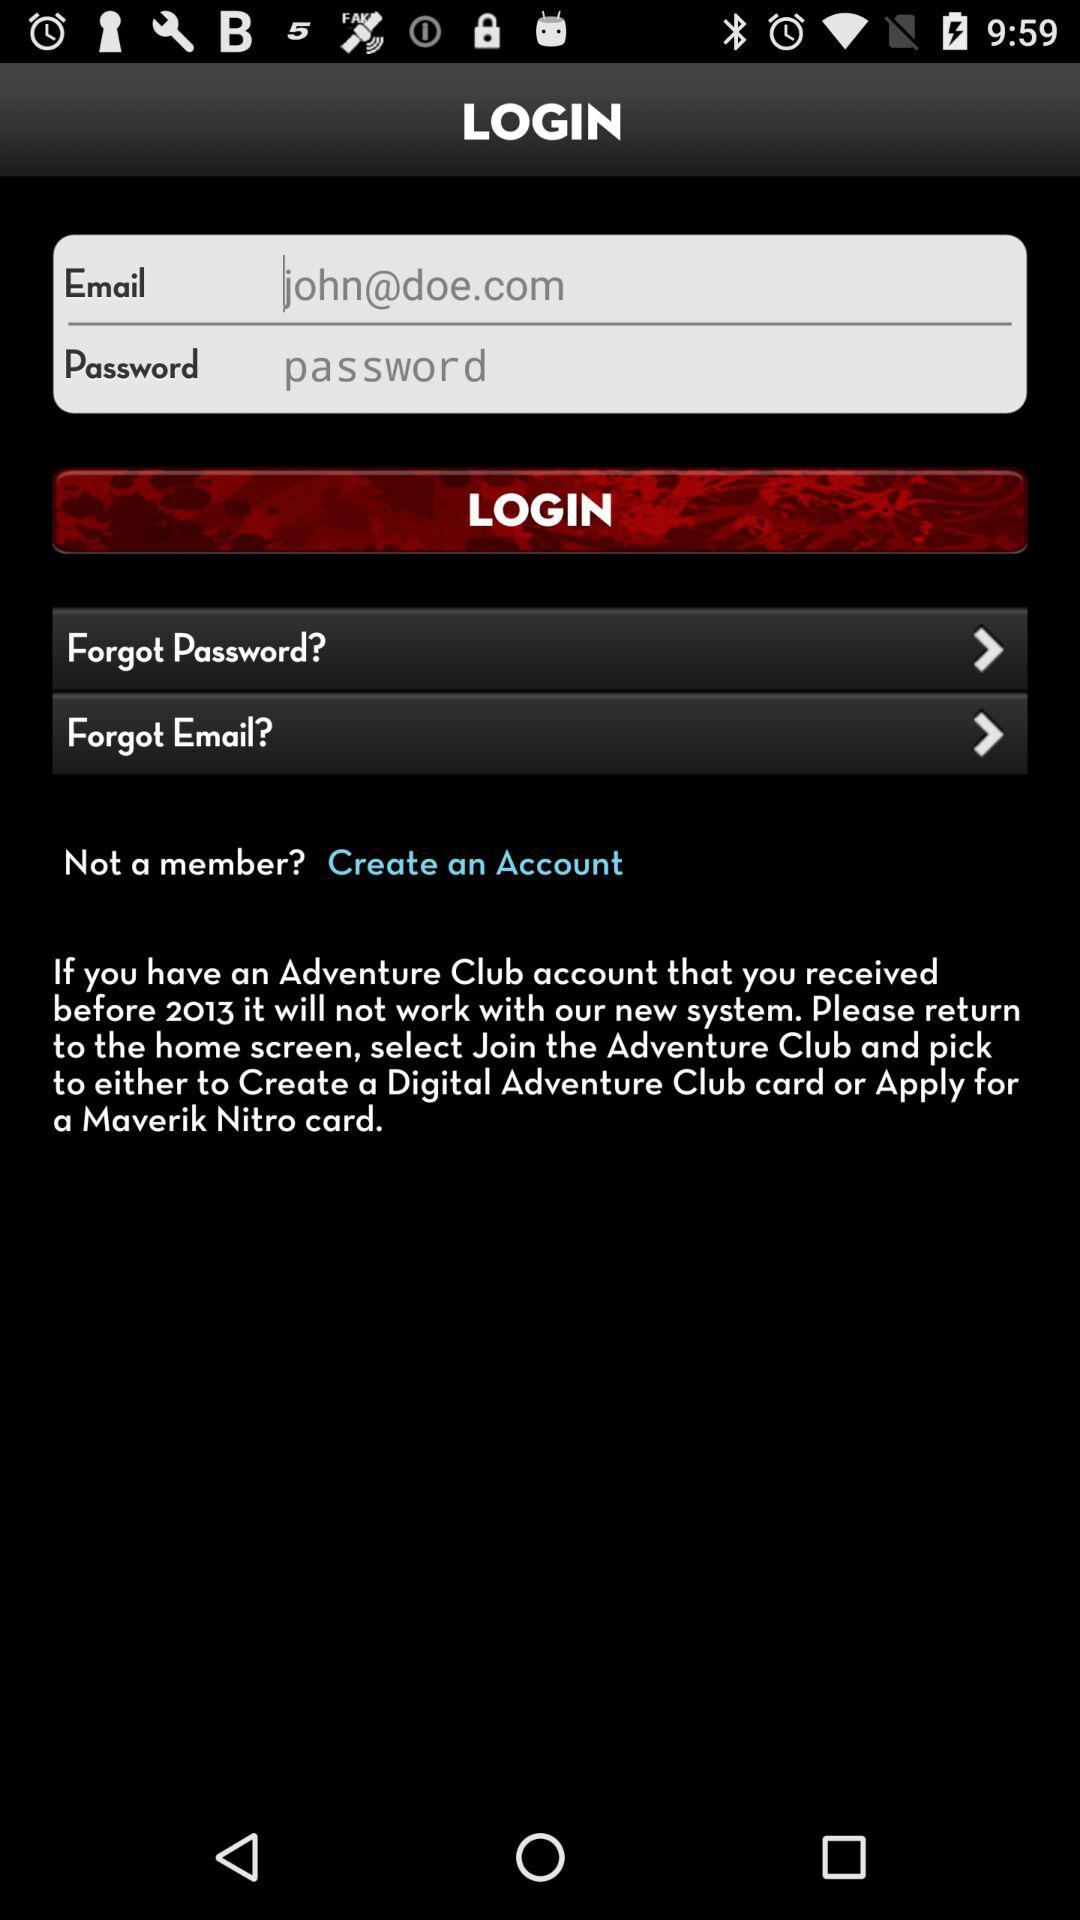When did the adventure club account received?
When the provided information is insufficient, respond with <no answer>. <no answer> 